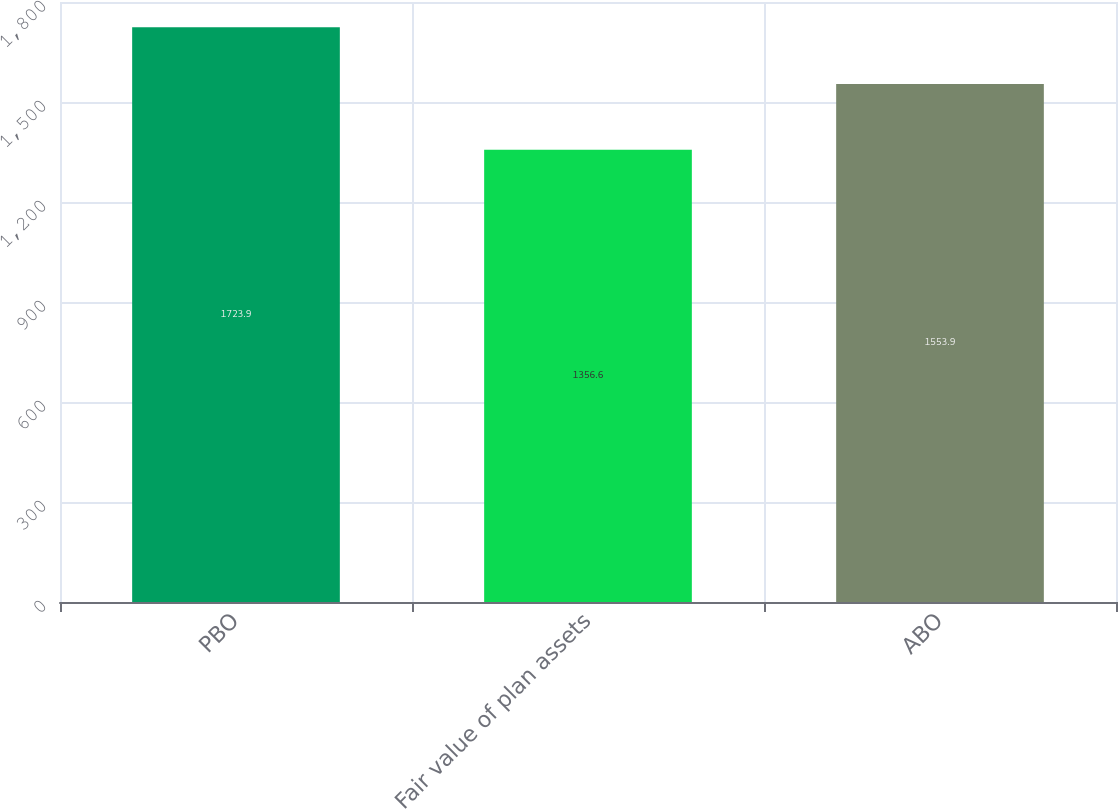Convert chart to OTSL. <chart><loc_0><loc_0><loc_500><loc_500><bar_chart><fcel>PBO<fcel>Fair value of plan assets<fcel>ABO<nl><fcel>1723.9<fcel>1356.6<fcel>1553.9<nl></chart> 